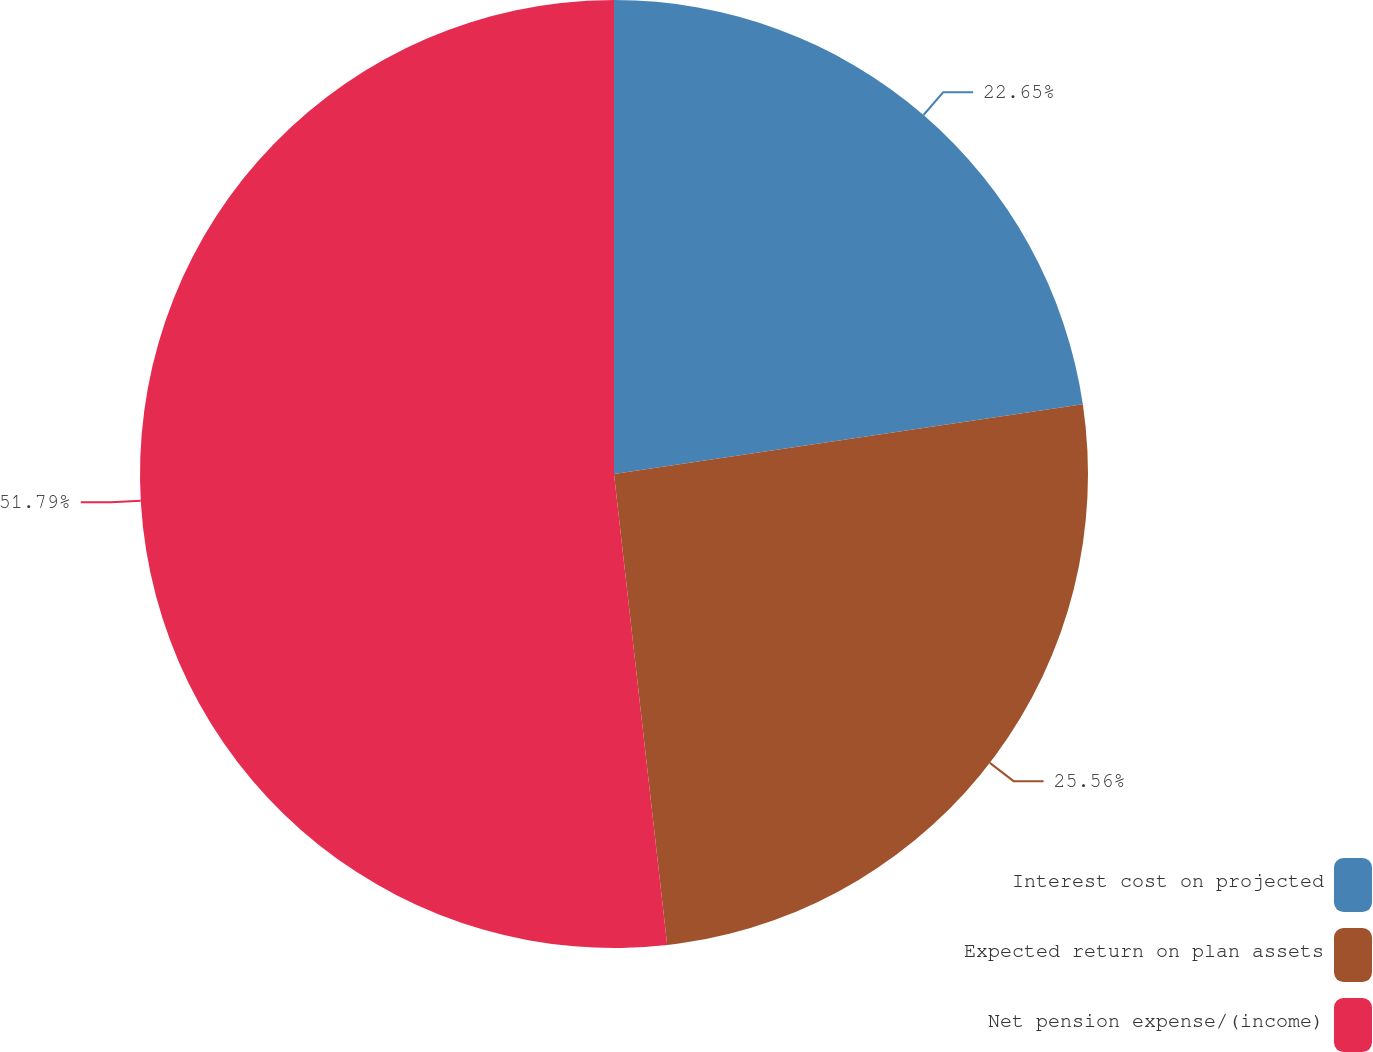Convert chart. <chart><loc_0><loc_0><loc_500><loc_500><pie_chart><fcel>Interest cost on projected<fcel>Expected return on plan assets<fcel>Net pension expense/(income)<nl><fcel>22.65%<fcel>25.56%<fcel>51.79%<nl></chart> 